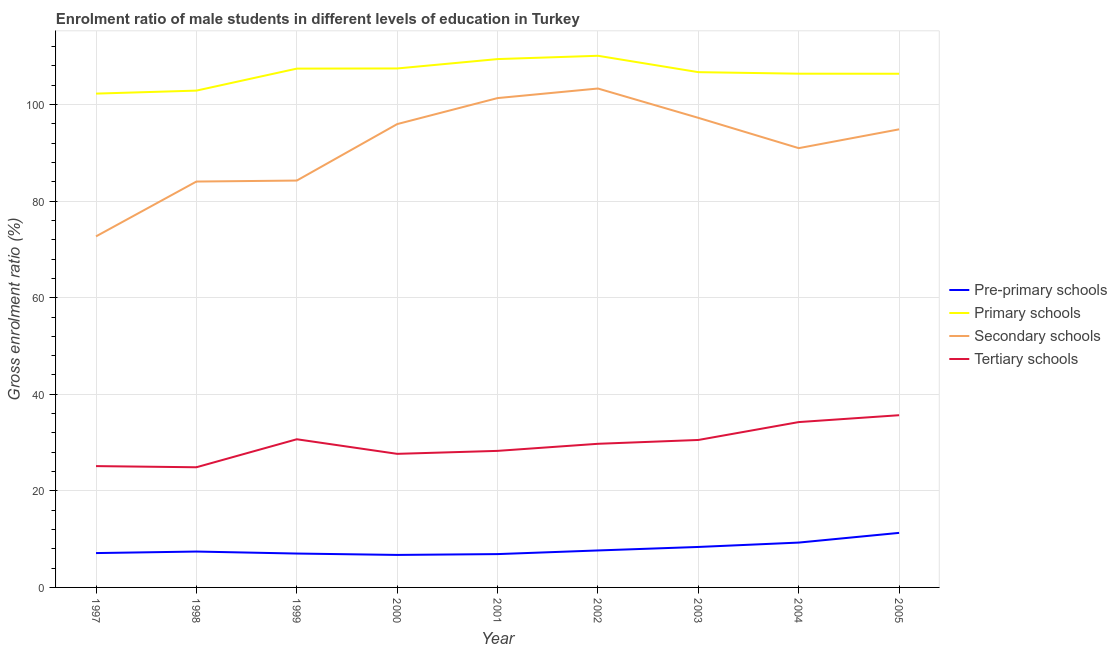How many different coloured lines are there?
Your answer should be very brief. 4. Does the line corresponding to gross enrolment ratio(female) in primary schools intersect with the line corresponding to gross enrolment ratio(female) in pre-primary schools?
Offer a very short reply. No. What is the gross enrolment ratio(female) in secondary schools in 1998?
Provide a short and direct response. 84.06. Across all years, what is the maximum gross enrolment ratio(female) in tertiary schools?
Your answer should be very brief. 35.67. Across all years, what is the minimum gross enrolment ratio(female) in tertiary schools?
Ensure brevity in your answer.  24.89. In which year was the gross enrolment ratio(female) in secondary schools minimum?
Keep it short and to the point. 1997. What is the total gross enrolment ratio(female) in tertiary schools in the graph?
Your response must be concise. 266.83. What is the difference between the gross enrolment ratio(female) in tertiary schools in 1999 and that in 2003?
Your answer should be compact. 0.15. What is the difference between the gross enrolment ratio(female) in pre-primary schools in 2002 and the gross enrolment ratio(female) in secondary schools in 2003?
Offer a terse response. -89.59. What is the average gross enrolment ratio(female) in primary schools per year?
Make the answer very short. 106.57. In the year 1998, what is the difference between the gross enrolment ratio(female) in primary schools and gross enrolment ratio(female) in tertiary schools?
Give a very brief answer. 78. What is the ratio of the gross enrolment ratio(female) in tertiary schools in 2000 to that in 2005?
Your response must be concise. 0.78. Is the difference between the gross enrolment ratio(female) in secondary schools in 2000 and 2003 greater than the difference between the gross enrolment ratio(female) in tertiary schools in 2000 and 2003?
Your response must be concise. Yes. What is the difference between the highest and the second highest gross enrolment ratio(female) in tertiary schools?
Your answer should be very brief. 1.42. What is the difference between the highest and the lowest gross enrolment ratio(female) in pre-primary schools?
Provide a succinct answer. 4.56. In how many years, is the gross enrolment ratio(female) in primary schools greater than the average gross enrolment ratio(female) in primary schools taken over all years?
Offer a terse response. 5. Is it the case that in every year, the sum of the gross enrolment ratio(female) in pre-primary schools and gross enrolment ratio(female) in secondary schools is greater than the sum of gross enrolment ratio(female) in tertiary schools and gross enrolment ratio(female) in primary schools?
Your answer should be very brief. Yes. Is the gross enrolment ratio(female) in pre-primary schools strictly less than the gross enrolment ratio(female) in tertiary schools over the years?
Your response must be concise. Yes. How many lines are there?
Ensure brevity in your answer.  4. How many years are there in the graph?
Provide a succinct answer. 9. What is the difference between two consecutive major ticks on the Y-axis?
Your answer should be very brief. 20. Does the graph contain grids?
Provide a succinct answer. Yes. How many legend labels are there?
Your answer should be very brief. 4. What is the title of the graph?
Provide a short and direct response. Enrolment ratio of male students in different levels of education in Turkey. What is the label or title of the X-axis?
Provide a succinct answer. Year. What is the label or title of the Y-axis?
Provide a succinct answer. Gross enrolment ratio (%). What is the Gross enrolment ratio (%) in Pre-primary schools in 1997?
Give a very brief answer. 7.11. What is the Gross enrolment ratio (%) in Primary schools in 1997?
Your answer should be very brief. 102.27. What is the Gross enrolment ratio (%) of Secondary schools in 1997?
Offer a very short reply. 72.7. What is the Gross enrolment ratio (%) of Tertiary schools in 1997?
Keep it short and to the point. 25.12. What is the Gross enrolment ratio (%) of Pre-primary schools in 1998?
Your answer should be very brief. 7.43. What is the Gross enrolment ratio (%) of Primary schools in 1998?
Provide a succinct answer. 102.89. What is the Gross enrolment ratio (%) in Secondary schools in 1998?
Your answer should be compact. 84.06. What is the Gross enrolment ratio (%) of Tertiary schools in 1998?
Provide a short and direct response. 24.89. What is the Gross enrolment ratio (%) in Pre-primary schools in 1999?
Provide a succinct answer. 7.02. What is the Gross enrolment ratio (%) in Primary schools in 1999?
Offer a very short reply. 107.44. What is the Gross enrolment ratio (%) of Secondary schools in 1999?
Make the answer very short. 84.26. What is the Gross enrolment ratio (%) of Tertiary schools in 1999?
Your response must be concise. 30.68. What is the Gross enrolment ratio (%) in Pre-primary schools in 2000?
Your response must be concise. 6.73. What is the Gross enrolment ratio (%) in Primary schools in 2000?
Make the answer very short. 107.48. What is the Gross enrolment ratio (%) in Secondary schools in 2000?
Ensure brevity in your answer.  95.96. What is the Gross enrolment ratio (%) of Tertiary schools in 2000?
Your response must be concise. 27.66. What is the Gross enrolment ratio (%) in Pre-primary schools in 2001?
Your response must be concise. 6.9. What is the Gross enrolment ratio (%) in Primary schools in 2001?
Give a very brief answer. 109.42. What is the Gross enrolment ratio (%) in Secondary schools in 2001?
Offer a terse response. 101.34. What is the Gross enrolment ratio (%) in Tertiary schools in 2001?
Ensure brevity in your answer.  28.28. What is the Gross enrolment ratio (%) of Pre-primary schools in 2002?
Provide a short and direct response. 7.66. What is the Gross enrolment ratio (%) of Primary schools in 2002?
Ensure brevity in your answer.  110.1. What is the Gross enrolment ratio (%) of Secondary schools in 2002?
Offer a very short reply. 103.32. What is the Gross enrolment ratio (%) of Tertiary schools in 2002?
Ensure brevity in your answer.  29.74. What is the Gross enrolment ratio (%) of Pre-primary schools in 2003?
Offer a very short reply. 8.38. What is the Gross enrolment ratio (%) of Primary schools in 2003?
Offer a terse response. 106.71. What is the Gross enrolment ratio (%) in Secondary schools in 2003?
Provide a succinct answer. 97.25. What is the Gross enrolment ratio (%) of Tertiary schools in 2003?
Offer a very short reply. 30.54. What is the Gross enrolment ratio (%) in Pre-primary schools in 2004?
Your answer should be compact. 9.29. What is the Gross enrolment ratio (%) in Primary schools in 2004?
Your answer should be very brief. 106.39. What is the Gross enrolment ratio (%) of Secondary schools in 2004?
Provide a succinct answer. 90.97. What is the Gross enrolment ratio (%) in Tertiary schools in 2004?
Your answer should be compact. 34.24. What is the Gross enrolment ratio (%) of Pre-primary schools in 2005?
Your answer should be compact. 11.3. What is the Gross enrolment ratio (%) in Primary schools in 2005?
Your answer should be very brief. 106.38. What is the Gross enrolment ratio (%) in Secondary schools in 2005?
Keep it short and to the point. 94.87. What is the Gross enrolment ratio (%) of Tertiary schools in 2005?
Provide a short and direct response. 35.67. Across all years, what is the maximum Gross enrolment ratio (%) of Pre-primary schools?
Keep it short and to the point. 11.3. Across all years, what is the maximum Gross enrolment ratio (%) in Primary schools?
Give a very brief answer. 110.1. Across all years, what is the maximum Gross enrolment ratio (%) of Secondary schools?
Ensure brevity in your answer.  103.32. Across all years, what is the maximum Gross enrolment ratio (%) in Tertiary schools?
Provide a short and direct response. 35.67. Across all years, what is the minimum Gross enrolment ratio (%) in Pre-primary schools?
Make the answer very short. 6.73. Across all years, what is the minimum Gross enrolment ratio (%) of Primary schools?
Your answer should be very brief. 102.27. Across all years, what is the minimum Gross enrolment ratio (%) in Secondary schools?
Your answer should be compact. 72.7. Across all years, what is the minimum Gross enrolment ratio (%) in Tertiary schools?
Offer a terse response. 24.89. What is the total Gross enrolment ratio (%) of Pre-primary schools in the graph?
Offer a terse response. 71.82. What is the total Gross enrolment ratio (%) in Primary schools in the graph?
Make the answer very short. 959.09. What is the total Gross enrolment ratio (%) in Secondary schools in the graph?
Ensure brevity in your answer.  824.73. What is the total Gross enrolment ratio (%) in Tertiary schools in the graph?
Keep it short and to the point. 266.83. What is the difference between the Gross enrolment ratio (%) of Pre-primary schools in 1997 and that in 1998?
Provide a succinct answer. -0.32. What is the difference between the Gross enrolment ratio (%) in Primary schools in 1997 and that in 1998?
Your answer should be very brief. -0.62. What is the difference between the Gross enrolment ratio (%) in Secondary schools in 1997 and that in 1998?
Ensure brevity in your answer.  -11.36. What is the difference between the Gross enrolment ratio (%) in Tertiary schools in 1997 and that in 1998?
Your answer should be very brief. 0.24. What is the difference between the Gross enrolment ratio (%) in Pre-primary schools in 1997 and that in 1999?
Your response must be concise. 0.09. What is the difference between the Gross enrolment ratio (%) of Primary schools in 1997 and that in 1999?
Provide a short and direct response. -5.18. What is the difference between the Gross enrolment ratio (%) in Secondary schools in 1997 and that in 1999?
Keep it short and to the point. -11.56. What is the difference between the Gross enrolment ratio (%) in Tertiary schools in 1997 and that in 1999?
Keep it short and to the point. -5.56. What is the difference between the Gross enrolment ratio (%) of Pre-primary schools in 1997 and that in 2000?
Ensure brevity in your answer.  0.38. What is the difference between the Gross enrolment ratio (%) of Primary schools in 1997 and that in 2000?
Make the answer very short. -5.21. What is the difference between the Gross enrolment ratio (%) in Secondary schools in 1997 and that in 2000?
Offer a very short reply. -23.25. What is the difference between the Gross enrolment ratio (%) of Tertiary schools in 1997 and that in 2000?
Your response must be concise. -2.54. What is the difference between the Gross enrolment ratio (%) of Pre-primary schools in 1997 and that in 2001?
Offer a very short reply. 0.21. What is the difference between the Gross enrolment ratio (%) in Primary schools in 1997 and that in 2001?
Your answer should be very brief. -7.15. What is the difference between the Gross enrolment ratio (%) of Secondary schools in 1997 and that in 2001?
Give a very brief answer. -28.64. What is the difference between the Gross enrolment ratio (%) of Tertiary schools in 1997 and that in 2001?
Keep it short and to the point. -3.16. What is the difference between the Gross enrolment ratio (%) of Pre-primary schools in 1997 and that in 2002?
Ensure brevity in your answer.  -0.55. What is the difference between the Gross enrolment ratio (%) in Primary schools in 1997 and that in 2002?
Provide a succinct answer. -7.83. What is the difference between the Gross enrolment ratio (%) in Secondary schools in 1997 and that in 2002?
Make the answer very short. -30.62. What is the difference between the Gross enrolment ratio (%) of Tertiary schools in 1997 and that in 2002?
Keep it short and to the point. -4.62. What is the difference between the Gross enrolment ratio (%) in Pre-primary schools in 1997 and that in 2003?
Your answer should be very brief. -1.27. What is the difference between the Gross enrolment ratio (%) in Primary schools in 1997 and that in 2003?
Your answer should be very brief. -4.44. What is the difference between the Gross enrolment ratio (%) of Secondary schools in 1997 and that in 2003?
Your answer should be very brief. -24.55. What is the difference between the Gross enrolment ratio (%) of Tertiary schools in 1997 and that in 2003?
Provide a short and direct response. -5.41. What is the difference between the Gross enrolment ratio (%) of Pre-primary schools in 1997 and that in 2004?
Your answer should be very brief. -2.18. What is the difference between the Gross enrolment ratio (%) in Primary schools in 1997 and that in 2004?
Offer a very short reply. -4.12. What is the difference between the Gross enrolment ratio (%) in Secondary schools in 1997 and that in 2004?
Give a very brief answer. -18.27. What is the difference between the Gross enrolment ratio (%) of Tertiary schools in 1997 and that in 2004?
Your answer should be compact. -9.12. What is the difference between the Gross enrolment ratio (%) of Pre-primary schools in 1997 and that in 2005?
Ensure brevity in your answer.  -4.18. What is the difference between the Gross enrolment ratio (%) of Primary schools in 1997 and that in 2005?
Offer a very short reply. -4.11. What is the difference between the Gross enrolment ratio (%) in Secondary schools in 1997 and that in 2005?
Your response must be concise. -22.17. What is the difference between the Gross enrolment ratio (%) in Tertiary schools in 1997 and that in 2005?
Give a very brief answer. -10.54. What is the difference between the Gross enrolment ratio (%) of Pre-primary schools in 1998 and that in 1999?
Offer a very short reply. 0.41. What is the difference between the Gross enrolment ratio (%) in Primary schools in 1998 and that in 1999?
Make the answer very short. -4.56. What is the difference between the Gross enrolment ratio (%) of Secondary schools in 1998 and that in 1999?
Offer a very short reply. -0.2. What is the difference between the Gross enrolment ratio (%) of Tertiary schools in 1998 and that in 1999?
Make the answer very short. -5.8. What is the difference between the Gross enrolment ratio (%) of Pre-primary schools in 1998 and that in 2000?
Provide a succinct answer. 0.7. What is the difference between the Gross enrolment ratio (%) of Primary schools in 1998 and that in 2000?
Offer a terse response. -4.59. What is the difference between the Gross enrolment ratio (%) of Secondary schools in 1998 and that in 2000?
Offer a very short reply. -11.9. What is the difference between the Gross enrolment ratio (%) of Tertiary schools in 1998 and that in 2000?
Your answer should be compact. -2.78. What is the difference between the Gross enrolment ratio (%) in Pre-primary schools in 1998 and that in 2001?
Give a very brief answer. 0.53. What is the difference between the Gross enrolment ratio (%) of Primary schools in 1998 and that in 2001?
Offer a terse response. -6.53. What is the difference between the Gross enrolment ratio (%) in Secondary schools in 1998 and that in 2001?
Ensure brevity in your answer.  -17.29. What is the difference between the Gross enrolment ratio (%) of Tertiary schools in 1998 and that in 2001?
Your answer should be compact. -3.4. What is the difference between the Gross enrolment ratio (%) in Pre-primary schools in 1998 and that in 2002?
Your answer should be compact. -0.23. What is the difference between the Gross enrolment ratio (%) of Primary schools in 1998 and that in 2002?
Give a very brief answer. -7.21. What is the difference between the Gross enrolment ratio (%) of Secondary schools in 1998 and that in 2002?
Provide a short and direct response. -19.27. What is the difference between the Gross enrolment ratio (%) in Tertiary schools in 1998 and that in 2002?
Provide a short and direct response. -4.86. What is the difference between the Gross enrolment ratio (%) of Pre-primary schools in 1998 and that in 2003?
Your answer should be compact. -0.95. What is the difference between the Gross enrolment ratio (%) in Primary schools in 1998 and that in 2003?
Provide a short and direct response. -3.82. What is the difference between the Gross enrolment ratio (%) in Secondary schools in 1998 and that in 2003?
Your answer should be very brief. -13.19. What is the difference between the Gross enrolment ratio (%) in Tertiary schools in 1998 and that in 2003?
Offer a very short reply. -5.65. What is the difference between the Gross enrolment ratio (%) of Pre-primary schools in 1998 and that in 2004?
Your answer should be very brief. -1.86. What is the difference between the Gross enrolment ratio (%) of Primary schools in 1998 and that in 2004?
Your answer should be compact. -3.5. What is the difference between the Gross enrolment ratio (%) of Secondary schools in 1998 and that in 2004?
Your answer should be compact. -6.92. What is the difference between the Gross enrolment ratio (%) of Tertiary schools in 1998 and that in 2004?
Provide a succinct answer. -9.36. What is the difference between the Gross enrolment ratio (%) in Pre-primary schools in 1998 and that in 2005?
Your answer should be very brief. -3.87. What is the difference between the Gross enrolment ratio (%) of Primary schools in 1998 and that in 2005?
Provide a short and direct response. -3.49. What is the difference between the Gross enrolment ratio (%) in Secondary schools in 1998 and that in 2005?
Your answer should be very brief. -10.81. What is the difference between the Gross enrolment ratio (%) in Tertiary schools in 1998 and that in 2005?
Offer a terse response. -10.78. What is the difference between the Gross enrolment ratio (%) of Pre-primary schools in 1999 and that in 2000?
Your response must be concise. 0.28. What is the difference between the Gross enrolment ratio (%) of Primary schools in 1999 and that in 2000?
Provide a succinct answer. -0.03. What is the difference between the Gross enrolment ratio (%) of Secondary schools in 1999 and that in 2000?
Offer a very short reply. -11.7. What is the difference between the Gross enrolment ratio (%) in Tertiary schools in 1999 and that in 2000?
Provide a short and direct response. 3.02. What is the difference between the Gross enrolment ratio (%) in Pre-primary schools in 1999 and that in 2001?
Your response must be concise. 0.11. What is the difference between the Gross enrolment ratio (%) of Primary schools in 1999 and that in 2001?
Keep it short and to the point. -1.97. What is the difference between the Gross enrolment ratio (%) in Secondary schools in 1999 and that in 2001?
Your response must be concise. -17.08. What is the difference between the Gross enrolment ratio (%) of Tertiary schools in 1999 and that in 2001?
Your answer should be very brief. 2.4. What is the difference between the Gross enrolment ratio (%) of Pre-primary schools in 1999 and that in 2002?
Ensure brevity in your answer.  -0.64. What is the difference between the Gross enrolment ratio (%) of Primary schools in 1999 and that in 2002?
Give a very brief answer. -2.66. What is the difference between the Gross enrolment ratio (%) in Secondary schools in 1999 and that in 2002?
Provide a succinct answer. -19.06. What is the difference between the Gross enrolment ratio (%) in Tertiary schools in 1999 and that in 2002?
Your response must be concise. 0.94. What is the difference between the Gross enrolment ratio (%) of Pre-primary schools in 1999 and that in 2003?
Make the answer very short. -1.37. What is the difference between the Gross enrolment ratio (%) in Primary schools in 1999 and that in 2003?
Make the answer very short. 0.73. What is the difference between the Gross enrolment ratio (%) of Secondary schools in 1999 and that in 2003?
Offer a terse response. -12.99. What is the difference between the Gross enrolment ratio (%) of Tertiary schools in 1999 and that in 2003?
Your answer should be compact. 0.15. What is the difference between the Gross enrolment ratio (%) of Pre-primary schools in 1999 and that in 2004?
Keep it short and to the point. -2.27. What is the difference between the Gross enrolment ratio (%) of Primary schools in 1999 and that in 2004?
Your answer should be compact. 1.05. What is the difference between the Gross enrolment ratio (%) of Secondary schools in 1999 and that in 2004?
Give a very brief answer. -6.71. What is the difference between the Gross enrolment ratio (%) in Tertiary schools in 1999 and that in 2004?
Keep it short and to the point. -3.56. What is the difference between the Gross enrolment ratio (%) in Pre-primary schools in 1999 and that in 2005?
Offer a terse response. -4.28. What is the difference between the Gross enrolment ratio (%) in Primary schools in 1999 and that in 2005?
Ensure brevity in your answer.  1.06. What is the difference between the Gross enrolment ratio (%) of Secondary schools in 1999 and that in 2005?
Your response must be concise. -10.61. What is the difference between the Gross enrolment ratio (%) in Tertiary schools in 1999 and that in 2005?
Your answer should be compact. -4.98. What is the difference between the Gross enrolment ratio (%) of Pre-primary schools in 2000 and that in 2001?
Keep it short and to the point. -0.17. What is the difference between the Gross enrolment ratio (%) of Primary schools in 2000 and that in 2001?
Offer a terse response. -1.94. What is the difference between the Gross enrolment ratio (%) of Secondary schools in 2000 and that in 2001?
Your response must be concise. -5.39. What is the difference between the Gross enrolment ratio (%) in Tertiary schools in 2000 and that in 2001?
Your answer should be compact. -0.62. What is the difference between the Gross enrolment ratio (%) of Pre-primary schools in 2000 and that in 2002?
Your answer should be compact. -0.93. What is the difference between the Gross enrolment ratio (%) of Primary schools in 2000 and that in 2002?
Offer a very short reply. -2.62. What is the difference between the Gross enrolment ratio (%) in Secondary schools in 2000 and that in 2002?
Your answer should be very brief. -7.37. What is the difference between the Gross enrolment ratio (%) in Tertiary schools in 2000 and that in 2002?
Your answer should be compact. -2.08. What is the difference between the Gross enrolment ratio (%) in Pre-primary schools in 2000 and that in 2003?
Offer a very short reply. -1.65. What is the difference between the Gross enrolment ratio (%) in Primary schools in 2000 and that in 2003?
Your answer should be very brief. 0.77. What is the difference between the Gross enrolment ratio (%) in Secondary schools in 2000 and that in 2003?
Your response must be concise. -1.29. What is the difference between the Gross enrolment ratio (%) of Tertiary schools in 2000 and that in 2003?
Keep it short and to the point. -2.87. What is the difference between the Gross enrolment ratio (%) in Pre-primary schools in 2000 and that in 2004?
Provide a succinct answer. -2.55. What is the difference between the Gross enrolment ratio (%) in Primary schools in 2000 and that in 2004?
Your response must be concise. 1.08. What is the difference between the Gross enrolment ratio (%) in Secondary schools in 2000 and that in 2004?
Ensure brevity in your answer.  4.98. What is the difference between the Gross enrolment ratio (%) in Tertiary schools in 2000 and that in 2004?
Provide a short and direct response. -6.58. What is the difference between the Gross enrolment ratio (%) in Pre-primary schools in 2000 and that in 2005?
Your answer should be very brief. -4.56. What is the difference between the Gross enrolment ratio (%) of Primary schools in 2000 and that in 2005?
Make the answer very short. 1.1. What is the difference between the Gross enrolment ratio (%) of Secondary schools in 2000 and that in 2005?
Ensure brevity in your answer.  1.08. What is the difference between the Gross enrolment ratio (%) in Tertiary schools in 2000 and that in 2005?
Give a very brief answer. -8. What is the difference between the Gross enrolment ratio (%) in Pre-primary schools in 2001 and that in 2002?
Offer a terse response. -0.75. What is the difference between the Gross enrolment ratio (%) of Primary schools in 2001 and that in 2002?
Ensure brevity in your answer.  -0.68. What is the difference between the Gross enrolment ratio (%) of Secondary schools in 2001 and that in 2002?
Make the answer very short. -1.98. What is the difference between the Gross enrolment ratio (%) of Tertiary schools in 2001 and that in 2002?
Ensure brevity in your answer.  -1.46. What is the difference between the Gross enrolment ratio (%) in Pre-primary schools in 2001 and that in 2003?
Make the answer very short. -1.48. What is the difference between the Gross enrolment ratio (%) of Primary schools in 2001 and that in 2003?
Ensure brevity in your answer.  2.71. What is the difference between the Gross enrolment ratio (%) of Secondary schools in 2001 and that in 2003?
Offer a very short reply. 4.09. What is the difference between the Gross enrolment ratio (%) in Tertiary schools in 2001 and that in 2003?
Provide a short and direct response. -2.26. What is the difference between the Gross enrolment ratio (%) of Pre-primary schools in 2001 and that in 2004?
Give a very brief answer. -2.38. What is the difference between the Gross enrolment ratio (%) of Primary schools in 2001 and that in 2004?
Your answer should be very brief. 3.03. What is the difference between the Gross enrolment ratio (%) in Secondary schools in 2001 and that in 2004?
Ensure brevity in your answer.  10.37. What is the difference between the Gross enrolment ratio (%) of Tertiary schools in 2001 and that in 2004?
Make the answer very short. -5.96. What is the difference between the Gross enrolment ratio (%) of Pre-primary schools in 2001 and that in 2005?
Make the answer very short. -4.39. What is the difference between the Gross enrolment ratio (%) in Primary schools in 2001 and that in 2005?
Provide a succinct answer. 3.04. What is the difference between the Gross enrolment ratio (%) in Secondary schools in 2001 and that in 2005?
Make the answer very short. 6.47. What is the difference between the Gross enrolment ratio (%) in Tertiary schools in 2001 and that in 2005?
Keep it short and to the point. -7.38. What is the difference between the Gross enrolment ratio (%) of Pre-primary schools in 2002 and that in 2003?
Offer a terse response. -0.72. What is the difference between the Gross enrolment ratio (%) in Primary schools in 2002 and that in 2003?
Your answer should be very brief. 3.39. What is the difference between the Gross enrolment ratio (%) of Secondary schools in 2002 and that in 2003?
Make the answer very short. 6.07. What is the difference between the Gross enrolment ratio (%) of Tertiary schools in 2002 and that in 2003?
Give a very brief answer. -0.79. What is the difference between the Gross enrolment ratio (%) of Pre-primary schools in 2002 and that in 2004?
Provide a succinct answer. -1.63. What is the difference between the Gross enrolment ratio (%) in Primary schools in 2002 and that in 2004?
Your response must be concise. 3.71. What is the difference between the Gross enrolment ratio (%) of Secondary schools in 2002 and that in 2004?
Your response must be concise. 12.35. What is the difference between the Gross enrolment ratio (%) in Tertiary schools in 2002 and that in 2004?
Provide a succinct answer. -4.5. What is the difference between the Gross enrolment ratio (%) in Pre-primary schools in 2002 and that in 2005?
Give a very brief answer. -3.64. What is the difference between the Gross enrolment ratio (%) in Primary schools in 2002 and that in 2005?
Offer a very short reply. 3.72. What is the difference between the Gross enrolment ratio (%) in Secondary schools in 2002 and that in 2005?
Ensure brevity in your answer.  8.45. What is the difference between the Gross enrolment ratio (%) of Tertiary schools in 2002 and that in 2005?
Offer a very short reply. -5.92. What is the difference between the Gross enrolment ratio (%) in Pre-primary schools in 2003 and that in 2004?
Keep it short and to the point. -0.9. What is the difference between the Gross enrolment ratio (%) of Primary schools in 2003 and that in 2004?
Offer a terse response. 0.32. What is the difference between the Gross enrolment ratio (%) of Secondary schools in 2003 and that in 2004?
Your answer should be compact. 6.28. What is the difference between the Gross enrolment ratio (%) in Tertiary schools in 2003 and that in 2004?
Your answer should be compact. -3.71. What is the difference between the Gross enrolment ratio (%) in Pre-primary schools in 2003 and that in 2005?
Provide a succinct answer. -2.91. What is the difference between the Gross enrolment ratio (%) in Primary schools in 2003 and that in 2005?
Offer a very short reply. 0.33. What is the difference between the Gross enrolment ratio (%) in Secondary schools in 2003 and that in 2005?
Offer a very short reply. 2.38. What is the difference between the Gross enrolment ratio (%) of Tertiary schools in 2003 and that in 2005?
Make the answer very short. -5.13. What is the difference between the Gross enrolment ratio (%) in Pre-primary schools in 2004 and that in 2005?
Make the answer very short. -2.01. What is the difference between the Gross enrolment ratio (%) of Primary schools in 2004 and that in 2005?
Provide a short and direct response. 0.01. What is the difference between the Gross enrolment ratio (%) in Secondary schools in 2004 and that in 2005?
Ensure brevity in your answer.  -3.9. What is the difference between the Gross enrolment ratio (%) in Tertiary schools in 2004 and that in 2005?
Your response must be concise. -1.42. What is the difference between the Gross enrolment ratio (%) of Pre-primary schools in 1997 and the Gross enrolment ratio (%) of Primary schools in 1998?
Make the answer very short. -95.78. What is the difference between the Gross enrolment ratio (%) in Pre-primary schools in 1997 and the Gross enrolment ratio (%) in Secondary schools in 1998?
Your answer should be very brief. -76.94. What is the difference between the Gross enrolment ratio (%) in Pre-primary schools in 1997 and the Gross enrolment ratio (%) in Tertiary schools in 1998?
Keep it short and to the point. -17.77. What is the difference between the Gross enrolment ratio (%) in Primary schools in 1997 and the Gross enrolment ratio (%) in Secondary schools in 1998?
Provide a succinct answer. 18.21. What is the difference between the Gross enrolment ratio (%) of Primary schools in 1997 and the Gross enrolment ratio (%) of Tertiary schools in 1998?
Ensure brevity in your answer.  77.38. What is the difference between the Gross enrolment ratio (%) of Secondary schools in 1997 and the Gross enrolment ratio (%) of Tertiary schools in 1998?
Your answer should be compact. 47.81. What is the difference between the Gross enrolment ratio (%) of Pre-primary schools in 1997 and the Gross enrolment ratio (%) of Primary schools in 1999?
Make the answer very short. -100.33. What is the difference between the Gross enrolment ratio (%) in Pre-primary schools in 1997 and the Gross enrolment ratio (%) in Secondary schools in 1999?
Your answer should be compact. -77.15. What is the difference between the Gross enrolment ratio (%) in Pre-primary schools in 1997 and the Gross enrolment ratio (%) in Tertiary schools in 1999?
Your answer should be compact. -23.57. What is the difference between the Gross enrolment ratio (%) of Primary schools in 1997 and the Gross enrolment ratio (%) of Secondary schools in 1999?
Provide a succinct answer. 18.01. What is the difference between the Gross enrolment ratio (%) in Primary schools in 1997 and the Gross enrolment ratio (%) in Tertiary schools in 1999?
Your response must be concise. 71.58. What is the difference between the Gross enrolment ratio (%) in Secondary schools in 1997 and the Gross enrolment ratio (%) in Tertiary schools in 1999?
Make the answer very short. 42.02. What is the difference between the Gross enrolment ratio (%) of Pre-primary schools in 1997 and the Gross enrolment ratio (%) of Primary schools in 2000?
Make the answer very short. -100.36. What is the difference between the Gross enrolment ratio (%) in Pre-primary schools in 1997 and the Gross enrolment ratio (%) in Secondary schools in 2000?
Provide a succinct answer. -88.84. What is the difference between the Gross enrolment ratio (%) of Pre-primary schools in 1997 and the Gross enrolment ratio (%) of Tertiary schools in 2000?
Your answer should be compact. -20.55. What is the difference between the Gross enrolment ratio (%) in Primary schools in 1997 and the Gross enrolment ratio (%) in Secondary schools in 2000?
Offer a very short reply. 6.31. What is the difference between the Gross enrolment ratio (%) in Primary schools in 1997 and the Gross enrolment ratio (%) in Tertiary schools in 2000?
Your response must be concise. 74.6. What is the difference between the Gross enrolment ratio (%) of Secondary schools in 1997 and the Gross enrolment ratio (%) of Tertiary schools in 2000?
Make the answer very short. 45.04. What is the difference between the Gross enrolment ratio (%) of Pre-primary schools in 1997 and the Gross enrolment ratio (%) of Primary schools in 2001?
Provide a succinct answer. -102.31. What is the difference between the Gross enrolment ratio (%) in Pre-primary schools in 1997 and the Gross enrolment ratio (%) in Secondary schools in 2001?
Give a very brief answer. -94.23. What is the difference between the Gross enrolment ratio (%) of Pre-primary schools in 1997 and the Gross enrolment ratio (%) of Tertiary schools in 2001?
Make the answer very short. -21.17. What is the difference between the Gross enrolment ratio (%) in Primary schools in 1997 and the Gross enrolment ratio (%) in Secondary schools in 2001?
Your answer should be very brief. 0.93. What is the difference between the Gross enrolment ratio (%) in Primary schools in 1997 and the Gross enrolment ratio (%) in Tertiary schools in 2001?
Your answer should be compact. 73.99. What is the difference between the Gross enrolment ratio (%) of Secondary schools in 1997 and the Gross enrolment ratio (%) of Tertiary schools in 2001?
Your response must be concise. 44.42. What is the difference between the Gross enrolment ratio (%) of Pre-primary schools in 1997 and the Gross enrolment ratio (%) of Primary schools in 2002?
Make the answer very short. -102.99. What is the difference between the Gross enrolment ratio (%) in Pre-primary schools in 1997 and the Gross enrolment ratio (%) in Secondary schools in 2002?
Offer a terse response. -96.21. What is the difference between the Gross enrolment ratio (%) in Pre-primary schools in 1997 and the Gross enrolment ratio (%) in Tertiary schools in 2002?
Your answer should be very brief. -22.63. What is the difference between the Gross enrolment ratio (%) in Primary schools in 1997 and the Gross enrolment ratio (%) in Secondary schools in 2002?
Make the answer very short. -1.05. What is the difference between the Gross enrolment ratio (%) in Primary schools in 1997 and the Gross enrolment ratio (%) in Tertiary schools in 2002?
Provide a short and direct response. 72.52. What is the difference between the Gross enrolment ratio (%) in Secondary schools in 1997 and the Gross enrolment ratio (%) in Tertiary schools in 2002?
Your answer should be very brief. 42.96. What is the difference between the Gross enrolment ratio (%) in Pre-primary schools in 1997 and the Gross enrolment ratio (%) in Primary schools in 2003?
Your answer should be compact. -99.6. What is the difference between the Gross enrolment ratio (%) of Pre-primary schools in 1997 and the Gross enrolment ratio (%) of Secondary schools in 2003?
Give a very brief answer. -90.14. What is the difference between the Gross enrolment ratio (%) in Pre-primary schools in 1997 and the Gross enrolment ratio (%) in Tertiary schools in 2003?
Offer a terse response. -23.43. What is the difference between the Gross enrolment ratio (%) in Primary schools in 1997 and the Gross enrolment ratio (%) in Secondary schools in 2003?
Keep it short and to the point. 5.02. What is the difference between the Gross enrolment ratio (%) of Primary schools in 1997 and the Gross enrolment ratio (%) of Tertiary schools in 2003?
Your response must be concise. 71.73. What is the difference between the Gross enrolment ratio (%) in Secondary schools in 1997 and the Gross enrolment ratio (%) in Tertiary schools in 2003?
Your response must be concise. 42.16. What is the difference between the Gross enrolment ratio (%) of Pre-primary schools in 1997 and the Gross enrolment ratio (%) of Primary schools in 2004?
Keep it short and to the point. -99.28. What is the difference between the Gross enrolment ratio (%) of Pre-primary schools in 1997 and the Gross enrolment ratio (%) of Secondary schools in 2004?
Your answer should be very brief. -83.86. What is the difference between the Gross enrolment ratio (%) of Pre-primary schools in 1997 and the Gross enrolment ratio (%) of Tertiary schools in 2004?
Provide a short and direct response. -27.13. What is the difference between the Gross enrolment ratio (%) of Primary schools in 1997 and the Gross enrolment ratio (%) of Secondary schools in 2004?
Offer a terse response. 11.3. What is the difference between the Gross enrolment ratio (%) of Primary schools in 1997 and the Gross enrolment ratio (%) of Tertiary schools in 2004?
Your response must be concise. 68.03. What is the difference between the Gross enrolment ratio (%) in Secondary schools in 1997 and the Gross enrolment ratio (%) in Tertiary schools in 2004?
Provide a short and direct response. 38.46. What is the difference between the Gross enrolment ratio (%) of Pre-primary schools in 1997 and the Gross enrolment ratio (%) of Primary schools in 2005?
Provide a succinct answer. -99.27. What is the difference between the Gross enrolment ratio (%) in Pre-primary schools in 1997 and the Gross enrolment ratio (%) in Secondary schools in 2005?
Your answer should be very brief. -87.76. What is the difference between the Gross enrolment ratio (%) in Pre-primary schools in 1997 and the Gross enrolment ratio (%) in Tertiary schools in 2005?
Provide a short and direct response. -28.55. What is the difference between the Gross enrolment ratio (%) in Primary schools in 1997 and the Gross enrolment ratio (%) in Secondary schools in 2005?
Keep it short and to the point. 7.4. What is the difference between the Gross enrolment ratio (%) of Primary schools in 1997 and the Gross enrolment ratio (%) of Tertiary schools in 2005?
Offer a terse response. 66.6. What is the difference between the Gross enrolment ratio (%) of Secondary schools in 1997 and the Gross enrolment ratio (%) of Tertiary schools in 2005?
Give a very brief answer. 37.04. What is the difference between the Gross enrolment ratio (%) in Pre-primary schools in 1998 and the Gross enrolment ratio (%) in Primary schools in 1999?
Your response must be concise. -100.01. What is the difference between the Gross enrolment ratio (%) in Pre-primary schools in 1998 and the Gross enrolment ratio (%) in Secondary schools in 1999?
Provide a short and direct response. -76.83. What is the difference between the Gross enrolment ratio (%) in Pre-primary schools in 1998 and the Gross enrolment ratio (%) in Tertiary schools in 1999?
Provide a succinct answer. -23.25. What is the difference between the Gross enrolment ratio (%) of Primary schools in 1998 and the Gross enrolment ratio (%) of Secondary schools in 1999?
Ensure brevity in your answer.  18.63. What is the difference between the Gross enrolment ratio (%) in Primary schools in 1998 and the Gross enrolment ratio (%) in Tertiary schools in 1999?
Your answer should be compact. 72.2. What is the difference between the Gross enrolment ratio (%) of Secondary schools in 1998 and the Gross enrolment ratio (%) of Tertiary schools in 1999?
Provide a succinct answer. 53.37. What is the difference between the Gross enrolment ratio (%) in Pre-primary schools in 1998 and the Gross enrolment ratio (%) in Primary schools in 2000?
Your answer should be compact. -100.05. What is the difference between the Gross enrolment ratio (%) of Pre-primary schools in 1998 and the Gross enrolment ratio (%) of Secondary schools in 2000?
Keep it short and to the point. -88.52. What is the difference between the Gross enrolment ratio (%) of Pre-primary schools in 1998 and the Gross enrolment ratio (%) of Tertiary schools in 2000?
Offer a terse response. -20.23. What is the difference between the Gross enrolment ratio (%) of Primary schools in 1998 and the Gross enrolment ratio (%) of Secondary schools in 2000?
Offer a very short reply. 6.93. What is the difference between the Gross enrolment ratio (%) in Primary schools in 1998 and the Gross enrolment ratio (%) in Tertiary schools in 2000?
Your answer should be very brief. 75.22. What is the difference between the Gross enrolment ratio (%) of Secondary schools in 1998 and the Gross enrolment ratio (%) of Tertiary schools in 2000?
Your response must be concise. 56.39. What is the difference between the Gross enrolment ratio (%) in Pre-primary schools in 1998 and the Gross enrolment ratio (%) in Primary schools in 2001?
Your response must be concise. -101.99. What is the difference between the Gross enrolment ratio (%) in Pre-primary schools in 1998 and the Gross enrolment ratio (%) in Secondary schools in 2001?
Ensure brevity in your answer.  -93.91. What is the difference between the Gross enrolment ratio (%) in Pre-primary schools in 1998 and the Gross enrolment ratio (%) in Tertiary schools in 2001?
Ensure brevity in your answer.  -20.85. What is the difference between the Gross enrolment ratio (%) in Primary schools in 1998 and the Gross enrolment ratio (%) in Secondary schools in 2001?
Make the answer very short. 1.55. What is the difference between the Gross enrolment ratio (%) of Primary schools in 1998 and the Gross enrolment ratio (%) of Tertiary schools in 2001?
Your answer should be very brief. 74.61. What is the difference between the Gross enrolment ratio (%) in Secondary schools in 1998 and the Gross enrolment ratio (%) in Tertiary schools in 2001?
Keep it short and to the point. 55.78. What is the difference between the Gross enrolment ratio (%) of Pre-primary schools in 1998 and the Gross enrolment ratio (%) of Primary schools in 2002?
Ensure brevity in your answer.  -102.67. What is the difference between the Gross enrolment ratio (%) of Pre-primary schools in 1998 and the Gross enrolment ratio (%) of Secondary schools in 2002?
Provide a short and direct response. -95.89. What is the difference between the Gross enrolment ratio (%) of Pre-primary schools in 1998 and the Gross enrolment ratio (%) of Tertiary schools in 2002?
Provide a succinct answer. -22.31. What is the difference between the Gross enrolment ratio (%) in Primary schools in 1998 and the Gross enrolment ratio (%) in Secondary schools in 2002?
Your answer should be compact. -0.43. What is the difference between the Gross enrolment ratio (%) of Primary schools in 1998 and the Gross enrolment ratio (%) of Tertiary schools in 2002?
Offer a terse response. 73.14. What is the difference between the Gross enrolment ratio (%) in Secondary schools in 1998 and the Gross enrolment ratio (%) in Tertiary schools in 2002?
Your response must be concise. 54.31. What is the difference between the Gross enrolment ratio (%) in Pre-primary schools in 1998 and the Gross enrolment ratio (%) in Primary schools in 2003?
Provide a succinct answer. -99.28. What is the difference between the Gross enrolment ratio (%) in Pre-primary schools in 1998 and the Gross enrolment ratio (%) in Secondary schools in 2003?
Offer a terse response. -89.82. What is the difference between the Gross enrolment ratio (%) of Pre-primary schools in 1998 and the Gross enrolment ratio (%) of Tertiary schools in 2003?
Give a very brief answer. -23.11. What is the difference between the Gross enrolment ratio (%) in Primary schools in 1998 and the Gross enrolment ratio (%) in Secondary schools in 2003?
Provide a succinct answer. 5.64. What is the difference between the Gross enrolment ratio (%) of Primary schools in 1998 and the Gross enrolment ratio (%) of Tertiary schools in 2003?
Provide a short and direct response. 72.35. What is the difference between the Gross enrolment ratio (%) of Secondary schools in 1998 and the Gross enrolment ratio (%) of Tertiary schools in 2003?
Offer a very short reply. 53.52. What is the difference between the Gross enrolment ratio (%) in Pre-primary schools in 1998 and the Gross enrolment ratio (%) in Primary schools in 2004?
Provide a short and direct response. -98.96. What is the difference between the Gross enrolment ratio (%) in Pre-primary schools in 1998 and the Gross enrolment ratio (%) in Secondary schools in 2004?
Your response must be concise. -83.54. What is the difference between the Gross enrolment ratio (%) of Pre-primary schools in 1998 and the Gross enrolment ratio (%) of Tertiary schools in 2004?
Ensure brevity in your answer.  -26.81. What is the difference between the Gross enrolment ratio (%) in Primary schools in 1998 and the Gross enrolment ratio (%) in Secondary schools in 2004?
Make the answer very short. 11.92. What is the difference between the Gross enrolment ratio (%) of Primary schools in 1998 and the Gross enrolment ratio (%) of Tertiary schools in 2004?
Keep it short and to the point. 68.65. What is the difference between the Gross enrolment ratio (%) in Secondary schools in 1998 and the Gross enrolment ratio (%) in Tertiary schools in 2004?
Offer a terse response. 49.81. What is the difference between the Gross enrolment ratio (%) in Pre-primary schools in 1998 and the Gross enrolment ratio (%) in Primary schools in 2005?
Keep it short and to the point. -98.95. What is the difference between the Gross enrolment ratio (%) in Pre-primary schools in 1998 and the Gross enrolment ratio (%) in Secondary schools in 2005?
Provide a short and direct response. -87.44. What is the difference between the Gross enrolment ratio (%) of Pre-primary schools in 1998 and the Gross enrolment ratio (%) of Tertiary schools in 2005?
Keep it short and to the point. -28.23. What is the difference between the Gross enrolment ratio (%) of Primary schools in 1998 and the Gross enrolment ratio (%) of Secondary schools in 2005?
Keep it short and to the point. 8.02. What is the difference between the Gross enrolment ratio (%) of Primary schools in 1998 and the Gross enrolment ratio (%) of Tertiary schools in 2005?
Provide a succinct answer. 67.22. What is the difference between the Gross enrolment ratio (%) of Secondary schools in 1998 and the Gross enrolment ratio (%) of Tertiary schools in 2005?
Your answer should be compact. 48.39. What is the difference between the Gross enrolment ratio (%) in Pre-primary schools in 1999 and the Gross enrolment ratio (%) in Primary schools in 2000?
Your answer should be very brief. -100.46. What is the difference between the Gross enrolment ratio (%) of Pre-primary schools in 1999 and the Gross enrolment ratio (%) of Secondary schools in 2000?
Provide a short and direct response. -88.94. What is the difference between the Gross enrolment ratio (%) of Pre-primary schools in 1999 and the Gross enrolment ratio (%) of Tertiary schools in 2000?
Your answer should be very brief. -20.65. What is the difference between the Gross enrolment ratio (%) of Primary schools in 1999 and the Gross enrolment ratio (%) of Secondary schools in 2000?
Offer a very short reply. 11.49. What is the difference between the Gross enrolment ratio (%) in Primary schools in 1999 and the Gross enrolment ratio (%) in Tertiary schools in 2000?
Keep it short and to the point. 79.78. What is the difference between the Gross enrolment ratio (%) in Secondary schools in 1999 and the Gross enrolment ratio (%) in Tertiary schools in 2000?
Give a very brief answer. 56.6. What is the difference between the Gross enrolment ratio (%) in Pre-primary schools in 1999 and the Gross enrolment ratio (%) in Primary schools in 2001?
Provide a succinct answer. -102.4. What is the difference between the Gross enrolment ratio (%) of Pre-primary schools in 1999 and the Gross enrolment ratio (%) of Secondary schools in 2001?
Your answer should be compact. -94.32. What is the difference between the Gross enrolment ratio (%) in Pre-primary schools in 1999 and the Gross enrolment ratio (%) in Tertiary schools in 2001?
Offer a terse response. -21.26. What is the difference between the Gross enrolment ratio (%) in Primary schools in 1999 and the Gross enrolment ratio (%) in Secondary schools in 2001?
Your answer should be very brief. 6.1. What is the difference between the Gross enrolment ratio (%) of Primary schools in 1999 and the Gross enrolment ratio (%) of Tertiary schools in 2001?
Make the answer very short. 79.16. What is the difference between the Gross enrolment ratio (%) of Secondary schools in 1999 and the Gross enrolment ratio (%) of Tertiary schools in 2001?
Offer a terse response. 55.98. What is the difference between the Gross enrolment ratio (%) of Pre-primary schools in 1999 and the Gross enrolment ratio (%) of Primary schools in 2002?
Ensure brevity in your answer.  -103.08. What is the difference between the Gross enrolment ratio (%) in Pre-primary schools in 1999 and the Gross enrolment ratio (%) in Secondary schools in 2002?
Ensure brevity in your answer.  -96.31. What is the difference between the Gross enrolment ratio (%) in Pre-primary schools in 1999 and the Gross enrolment ratio (%) in Tertiary schools in 2002?
Offer a very short reply. -22.73. What is the difference between the Gross enrolment ratio (%) of Primary schools in 1999 and the Gross enrolment ratio (%) of Secondary schools in 2002?
Give a very brief answer. 4.12. What is the difference between the Gross enrolment ratio (%) of Primary schools in 1999 and the Gross enrolment ratio (%) of Tertiary schools in 2002?
Offer a very short reply. 77.7. What is the difference between the Gross enrolment ratio (%) in Secondary schools in 1999 and the Gross enrolment ratio (%) in Tertiary schools in 2002?
Your response must be concise. 54.52. What is the difference between the Gross enrolment ratio (%) in Pre-primary schools in 1999 and the Gross enrolment ratio (%) in Primary schools in 2003?
Your answer should be very brief. -99.69. What is the difference between the Gross enrolment ratio (%) in Pre-primary schools in 1999 and the Gross enrolment ratio (%) in Secondary schools in 2003?
Provide a succinct answer. -90.23. What is the difference between the Gross enrolment ratio (%) in Pre-primary schools in 1999 and the Gross enrolment ratio (%) in Tertiary schools in 2003?
Keep it short and to the point. -23.52. What is the difference between the Gross enrolment ratio (%) in Primary schools in 1999 and the Gross enrolment ratio (%) in Secondary schools in 2003?
Your response must be concise. 10.2. What is the difference between the Gross enrolment ratio (%) in Primary schools in 1999 and the Gross enrolment ratio (%) in Tertiary schools in 2003?
Provide a short and direct response. 76.91. What is the difference between the Gross enrolment ratio (%) of Secondary schools in 1999 and the Gross enrolment ratio (%) of Tertiary schools in 2003?
Make the answer very short. 53.72. What is the difference between the Gross enrolment ratio (%) of Pre-primary schools in 1999 and the Gross enrolment ratio (%) of Primary schools in 2004?
Provide a succinct answer. -99.37. What is the difference between the Gross enrolment ratio (%) of Pre-primary schools in 1999 and the Gross enrolment ratio (%) of Secondary schools in 2004?
Keep it short and to the point. -83.96. What is the difference between the Gross enrolment ratio (%) in Pre-primary schools in 1999 and the Gross enrolment ratio (%) in Tertiary schools in 2004?
Your answer should be compact. -27.23. What is the difference between the Gross enrolment ratio (%) in Primary schools in 1999 and the Gross enrolment ratio (%) in Secondary schools in 2004?
Your answer should be very brief. 16.47. What is the difference between the Gross enrolment ratio (%) in Primary schools in 1999 and the Gross enrolment ratio (%) in Tertiary schools in 2004?
Keep it short and to the point. 73.2. What is the difference between the Gross enrolment ratio (%) in Secondary schools in 1999 and the Gross enrolment ratio (%) in Tertiary schools in 2004?
Provide a succinct answer. 50.02. What is the difference between the Gross enrolment ratio (%) in Pre-primary schools in 1999 and the Gross enrolment ratio (%) in Primary schools in 2005?
Your answer should be compact. -99.36. What is the difference between the Gross enrolment ratio (%) in Pre-primary schools in 1999 and the Gross enrolment ratio (%) in Secondary schools in 2005?
Your answer should be very brief. -87.85. What is the difference between the Gross enrolment ratio (%) of Pre-primary schools in 1999 and the Gross enrolment ratio (%) of Tertiary schools in 2005?
Offer a terse response. -28.65. What is the difference between the Gross enrolment ratio (%) in Primary schools in 1999 and the Gross enrolment ratio (%) in Secondary schools in 2005?
Provide a succinct answer. 12.57. What is the difference between the Gross enrolment ratio (%) in Primary schools in 1999 and the Gross enrolment ratio (%) in Tertiary schools in 2005?
Offer a terse response. 71.78. What is the difference between the Gross enrolment ratio (%) of Secondary schools in 1999 and the Gross enrolment ratio (%) of Tertiary schools in 2005?
Your response must be concise. 48.59. What is the difference between the Gross enrolment ratio (%) in Pre-primary schools in 2000 and the Gross enrolment ratio (%) in Primary schools in 2001?
Make the answer very short. -102.69. What is the difference between the Gross enrolment ratio (%) of Pre-primary schools in 2000 and the Gross enrolment ratio (%) of Secondary schools in 2001?
Your answer should be compact. -94.61. What is the difference between the Gross enrolment ratio (%) of Pre-primary schools in 2000 and the Gross enrolment ratio (%) of Tertiary schools in 2001?
Give a very brief answer. -21.55. What is the difference between the Gross enrolment ratio (%) in Primary schools in 2000 and the Gross enrolment ratio (%) in Secondary schools in 2001?
Your answer should be very brief. 6.13. What is the difference between the Gross enrolment ratio (%) of Primary schools in 2000 and the Gross enrolment ratio (%) of Tertiary schools in 2001?
Ensure brevity in your answer.  79.2. What is the difference between the Gross enrolment ratio (%) in Secondary schools in 2000 and the Gross enrolment ratio (%) in Tertiary schools in 2001?
Provide a succinct answer. 67.67. What is the difference between the Gross enrolment ratio (%) of Pre-primary schools in 2000 and the Gross enrolment ratio (%) of Primary schools in 2002?
Your answer should be very brief. -103.37. What is the difference between the Gross enrolment ratio (%) in Pre-primary schools in 2000 and the Gross enrolment ratio (%) in Secondary schools in 2002?
Your response must be concise. -96.59. What is the difference between the Gross enrolment ratio (%) in Pre-primary schools in 2000 and the Gross enrolment ratio (%) in Tertiary schools in 2002?
Provide a succinct answer. -23.01. What is the difference between the Gross enrolment ratio (%) in Primary schools in 2000 and the Gross enrolment ratio (%) in Secondary schools in 2002?
Your answer should be very brief. 4.15. What is the difference between the Gross enrolment ratio (%) of Primary schools in 2000 and the Gross enrolment ratio (%) of Tertiary schools in 2002?
Your answer should be compact. 77.73. What is the difference between the Gross enrolment ratio (%) in Secondary schools in 2000 and the Gross enrolment ratio (%) in Tertiary schools in 2002?
Provide a short and direct response. 66.21. What is the difference between the Gross enrolment ratio (%) in Pre-primary schools in 2000 and the Gross enrolment ratio (%) in Primary schools in 2003?
Provide a short and direct response. -99.98. What is the difference between the Gross enrolment ratio (%) of Pre-primary schools in 2000 and the Gross enrolment ratio (%) of Secondary schools in 2003?
Offer a very short reply. -90.52. What is the difference between the Gross enrolment ratio (%) of Pre-primary schools in 2000 and the Gross enrolment ratio (%) of Tertiary schools in 2003?
Provide a succinct answer. -23.8. What is the difference between the Gross enrolment ratio (%) of Primary schools in 2000 and the Gross enrolment ratio (%) of Secondary schools in 2003?
Provide a succinct answer. 10.23. What is the difference between the Gross enrolment ratio (%) of Primary schools in 2000 and the Gross enrolment ratio (%) of Tertiary schools in 2003?
Keep it short and to the point. 76.94. What is the difference between the Gross enrolment ratio (%) in Secondary schools in 2000 and the Gross enrolment ratio (%) in Tertiary schools in 2003?
Your answer should be very brief. 65.42. What is the difference between the Gross enrolment ratio (%) of Pre-primary schools in 2000 and the Gross enrolment ratio (%) of Primary schools in 2004?
Your response must be concise. -99.66. What is the difference between the Gross enrolment ratio (%) in Pre-primary schools in 2000 and the Gross enrolment ratio (%) in Secondary schools in 2004?
Make the answer very short. -84.24. What is the difference between the Gross enrolment ratio (%) in Pre-primary schools in 2000 and the Gross enrolment ratio (%) in Tertiary schools in 2004?
Provide a short and direct response. -27.51. What is the difference between the Gross enrolment ratio (%) of Primary schools in 2000 and the Gross enrolment ratio (%) of Secondary schools in 2004?
Provide a short and direct response. 16.5. What is the difference between the Gross enrolment ratio (%) in Primary schools in 2000 and the Gross enrolment ratio (%) in Tertiary schools in 2004?
Offer a very short reply. 73.23. What is the difference between the Gross enrolment ratio (%) of Secondary schools in 2000 and the Gross enrolment ratio (%) of Tertiary schools in 2004?
Provide a succinct answer. 61.71. What is the difference between the Gross enrolment ratio (%) of Pre-primary schools in 2000 and the Gross enrolment ratio (%) of Primary schools in 2005?
Your answer should be very brief. -99.65. What is the difference between the Gross enrolment ratio (%) of Pre-primary schools in 2000 and the Gross enrolment ratio (%) of Secondary schools in 2005?
Make the answer very short. -88.14. What is the difference between the Gross enrolment ratio (%) in Pre-primary schools in 2000 and the Gross enrolment ratio (%) in Tertiary schools in 2005?
Ensure brevity in your answer.  -28.93. What is the difference between the Gross enrolment ratio (%) of Primary schools in 2000 and the Gross enrolment ratio (%) of Secondary schools in 2005?
Give a very brief answer. 12.61. What is the difference between the Gross enrolment ratio (%) of Primary schools in 2000 and the Gross enrolment ratio (%) of Tertiary schools in 2005?
Ensure brevity in your answer.  71.81. What is the difference between the Gross enrolment ratio (%) of Secondary schools in 2000 and the Gross enrolment ratio (%) of Tertiary schools in 2005?
Provide a succinct answer. 60.29. What is the difference between the Gross enrolment ratio (%) of Pre-primary schools in 2001 and the Gross enrolment ratio (%) of Primary schools in 2002?
Your response must be concise. -103.2. What is the difference between the Gross enrolment ratio (%) of Pre-primary schools in 2001 and the Gross enrolment ratio (%) of Secondary schools in 2002?
Keep it short and to the point. -96.42. What is the difference between the Gross enrolment ratio (%) of Pre-primary schools in 2001 and the Gross enrolment ratio (%) of Tertiary schools in 2002?
Your answer should be very brief. -22.84. What is the difference between the Gross enrolment ratio (%) in Primary schools in 2001 and the Gross enrolment ratio (%) in Secondary schools in 2002?
Ensure brevity in your answer.  6.1. What is the difference between the Gross enrolment ratio (%) of Primary schools in 2001 and the Gross enrolment ratio (%) of Tertiary schools in 2002?
Make the answer very short. 79.67. What is the difference between the Gross enrolment ratio (%) in Secondary schools in 2001 and the Gross enrolment ratio (%) in Tertiary schools in 2002?
Make the answer very short. 71.6. What is the difference between the Gross enrolment ratio (%) in Pre-primary schools in 2001 and the Gross enrolment ratio (%) in Primary schools in 2003?
Your answer should be very brief. -99.81. What is the difference between the Gross enrolment ratio (%) of Pre-primary schools in 2001 and the Gross enrolment ratio (%) of Secondary schools in 2003?
Keep it short and to the point. -90.34. What is the difference between the Gross enrolment ratio (%) of Pre-primary schools in 2001 and the Gross enrolment ratio (%) of Tertiary schools in 2003?
Ensure brevity in your answer.  -23.63. What is the difference between the Gross enrolment ratio (%) in Primary schools in 2001 and the Gross enrolment ratio (%) in Secondary schools in 2003?
Offer a terse response. 12.17. What is the difference between the Gross enrolment ratio (%) of Primary schools in 2001 and the Gross enrolment ratio (%) of Tertiary schools in 2003?
Your answer should be very brief. 78.88. What is the difference between the Gross enrolment ratio (%) of Secondary schools in 2001 and the Gross enrolment ratio (%) of Tertiary schools in 2003?
Keep it short and to the point. 70.8. What is the difference between the Gross enrolment ratio (%) in Pre-primary schools in 2001 and the Gross enrolment ratio (%) in Primary schools in 2004?
Ensure brevity in your answer.  -99.49. What is the difference between the Gross enrolment ratio (%) in Pre-primary schools in 2001 and the Gross enrolment ratio (%) in Secondary schools in 2004?
Give a very brief answer. -84.07. What is the difference between the Gross enrolment ratio (%) in Pre-primary schools in 2001 and the Gross enrolment ratio (%) in Tertiary schools in 2004?
Your answer should be very brief. -27.34. What is the difference between the Gross enrolment ratio (%) of Primary schools in 2001 and the Gross enrolment ratio (%) of Secondary schools in 2004?
Provide a succinct answer. 18.45. What is the difference between the Gross enrolment ratio (%) of Primary schools in 2001 and the Gross enrolment ratio (%) of Tertiary schools in 2004?
Keep it short and to the point. 75.18. What is the difference between the Gross enrolment ratio (%) in Secondary schools in 2001 and the Gross enrolment ratio (%) in Tertiary schools in 2004?
Offer a terse response. 67.1. What is the difference between the Gross enrolment ratio (%) of Pre-primary schools in 2001 and the Gross enrolment ratio (%) of Primary schools in 2005?
Provide a short and direct response. -99.48. What is the difference between the Gross enrolment ratio (%) of Pre-primary schools in 2001 and the Gross enrolment ratio (%) of Secondary schools in 2005?
Your answer should be compact. -87.97. What is the difference between the Gross enrolment ratio (%) of Pre-primary schools in 2001 and the Gross enrolment ratio (%) of Tertiary schools in 2005?
Your answer should be very brief. -28.76. What is the difference between the Gross enrolment ratio (%) of Primary schools in 2001 and the Gross enrolment ratio (%) of Secondary schools in 2005?
Provide a succinct answer. 14.55. What is the difference between the Gross enrolment ratio (%) of Primary schools in 2001 and the Gross enrolment ratio (%) of Tertiary schools in 2005?
Provide a succinct answer. 73.75. What is the difference between the Gross enrolment ratio (%) in Secondary schools in 2001 and the Gross enrolment ratio (%) in Tertiary schools in 2005?
Your answer should be compact. 65.68. What is the difference between the Gross enrolment ratio (%) of Pre-primary schools in 2002 and the Gross enrolment ratio (%) of Primary schools in 2003?
Provide a short and direct response. -99.05. What is the difference between the Gross enrolment ratio (%) in Pre-primary schools in 2002 and the Gross enrolment ratio (%) in Secondary schools in 2003?
Keep it short and to the point. -89.59. What is the difference between the Gross enrolment ratio (%) in Pre-primary schools in 2002 and the Gross enrolment ratio (%) in Tertiary schools in 2003?
Provide a succinct answer. -22.88. What is the difference between the Gross enrolment ratio (%) in Primary schools in 2002 and the Gross enrolment ratio (%) in Secondary schools in 2003?
Your answer should be compact. 12.85. What is the difference between the Gross enrolment ratio (%) in Primary schools in 2002 and the Gross enrolment ratio (%) in Tertiary schools in 2003?
Provide a short and direct response. 79.56. What is the difference between the Gross enrolment ratio (%) in Secondary schools in 2002 and the Gross enrolment ratio (%) in Tertiary schools in 2003?
Your response must be concise. 72.79. What is the difference between the Gross enrolment ratio (%) in Pre-primary schools in 2002 and the Gross enrolment ratio (%) in Primary schools in 2004?
Provide a short and direct response. -98.73. What is the difference between the Gross enrolment ratio (%) in Pre-primary schools in 2002 and the Gross enrolment ratio (%) in Secondary schools in 2004?
Keep it short and to the point. -83.31. What is the difference between the Gross enrolment ratio (%) of Pre-primary schools in 2002 and the Gross enrolment ratio (%) of Tertiary schools in 2004?
Provide a succinct answer. -26.58. What is the difference between the Gross enrolment ratio (%) of Primary schools in 2002 and the Gross enrolment ratio (%) of Secondary schools in 2004?
Offer a terse response. 19.13. What is the difference between the Gross enrolment ratio (%) of Primary schools in 2002 and the Gross enrolment ratio (%) of Tertiary schools in 2004?
Provide a succinct answer. 75.86. What is the difference between the Gross enrolment ratio (%) of Secondary schools in 2002 and the Gross enrolment ratio (%) of Tertiary schools in 2004?
Your answer should be compact. 69.08. What is the difference between the Gross enrolment ratio (%) of Pre-primary schools in 2002 and the Gross enrolment ratio (%) of Primary schools in 2005?
Your response must be concise. -98.72. What is the difference between the Gross enrolment ratio (%) in Pre-primary schools in 2002 and the Gross enrolment ratio (%) in Secondary schools in 2005?
Provide a short and direct response. -87.21. What is the difference between the Gross enrolment ratio (%) in Pre-primary schools in 2002 and the Gross enrolment ratio (%) in Tertiary schools in 2005?
Your answer should be very brief. -28.01. What is the difference between the Gross enrolment ratio (%) of Primary schools in 2002 and the Gross enrolment ratio (%) of Secondary schools in 2005?
Provide a succinct answer. 15.23. What is the difference between the Gross enrolment ratio (%) in Primary schools in 2002 and the Gross enrolment ratio (%) in Tertiary schools in 2005?
Ensure brevity in your answer.  74.44. What is the difference between the Gross enrolment ratio (%) in Secondary schools in 2002 and the Gross enrolment ratio (%) in Tertiary schools in 2005?
Provide a short and direct response. 67.66. What is the difference between the Gross enrolment ratio (%) in Pre-primary schools in 2003 and the Gross enrolment ratio (%) in Primary schools in 2004?
Offer a terse response. -98.01. What is the difference between the Gross enrolment ratio (%) in Pre-primary schools in 2003 and the Gross enrolment ratio (%) in Secondary schools in 2004?
Make the answer very short. -82.59. What is the difference between the Gross enrolment ratio (%) in Pre-primary schools in 2003 and the Gross enrolment ratio (%) in Tertiary schools in 2004?
Ensure brevity in your answer.  -25.86. What is the difference between the Gross enrolment ratio (%) of Primary schools in 2003 and the Gross enrolment ratio (%) of Secondary schools in 2004?
Keep it short and to the point. 15.74. What is the difference between the Gross enrolment ratio (%) of Primary schools in 2003 and the Gross enrolment ratio (%) of Tertiary schools in 2004?
Your answer should be very brief. 72.47. What is the difference between the Gross enrolment ratio (%) of Secondary schools in 2003 and the Gross enrolment ratio (%) of Tertiary schools in 2004?
Your answer should be very brief. 63.01. What is the difference between the Gross enrolment ratio (%) in Pre-primary schools in 2003 and the Gross enrolment ratio (%) in Primary schools in 2005?
Your answer should be very brief. -98. What is the difference between the Gross enrolment ratio (%) of Pre-primary schools in 2003 and the Gross enrolment ratio (%) of Secondary schools in 2005?
Keep it short and to the point. -86.49. What is the difference between the Gross enrolment ratio (%) in Pre-primary schools in 2003 and the Gross enrolment ratio (%) in Tertiary schools in 2005?
Give a very brief answer. -27.28. What is the difference between the Gross enrolment ratio (%) in Primary schools in 2003 and the Gross enrolment ratio (%) in Secondary schools in 2005?
Make the answer very short. 11.84. What is the difference between the Gross enrolment ratio (%) of Primary schools in 2003 and the Gross enrolment ratio (%) of Tertiary schools in 2005?
Your response must be concise. 71.05. What is the difference between the Gross enrolment ratio (%) of Secondary schools in 2003 and the Gross enrolment ratio (%) of Tertiary schools in 2005?
Offer a terse response. 61.58. What is the difference between the Gross enrolment ratio (%) in Pre-primary schools in 2004 and the Gross enrolment ratio (%) in Primary schools in 2005?
Your answer should be compact. -97.09. What is the difference between the Gross enrolment ratio (%) of Pre-primary schools in 2004 and the Gross enrolment ratio (%) of Secondary schools in 2005?
Your answer should be compact. -85.58. What is the difference between the Gross enrolment ratio (%) in Pre-primary schools in 2004 and the Gross enrolment ratio (%) in Tertiary schools in 2005?
Your answer should be very brief. -26.38. What is the difference between the Gross enrolment ratio (%) in Primary schools in 2004 and the Gross enrolment ratio (%) in Secondary schools in 2005?
Provide a succinct answer. 11.52. What is the difference between the Gross enrolment ratio (%) of Primary schools in 2004 and the Gross enrolment ratio (%) of Tertiary schools in 2005?
Your response must be concise. 70.73. What is the difference between the Gross enrolment ratio (%) in Secondary schools in 2004 and the Gross enrolment ratio (%) in Tertiary schools in 2005?
Ensure brevity in your answer.  55.31. What is the average Gross enrolment ratio (%) of Pre-primary schools per year?
Ensure brevity in your answer.  7.98. What is the average Gross enrolment ratio (%) of Primary schools per year?
Offer a terse response. 106.56. What is the average Gross enrolment ratio (%) of Secondary schools per year?
Provide a succinct answer. 91.64. What is the average Gross enrolment ratio (%) of Tertiary schools per year?
Ensure brevity in your answer.  29.65. In the year 1997, what is the difference between the Gross enrolment ratio (%) in Pre-primary schools and Gross enrolment ratio (%) in Primary schools?
Ensure brevity in your answer.  -95.16. In the year 1997, what is the difference between the Gross enrolment ratio (%) of Pre-primary schools and Gross enrolment ratio (%) of Secondary schools?
Your response must be concise. -65.59. In the year 1997, what is the difference between the Gross enrolment ratio (%) in Pre-primary schools and Gross enrolment ratio (%) in Tertiary schools?
Provide a short and direct response. -18.01. In the year 1997, what is the difference between the Gross enrolment ratio (%) in Primary schools and Gross enrolment ratio (%) in Secondary schools?
Make the answer very short. 29.57. In the year 1997, what is the difference between the Gross enrolment ratio (%) of Primary schools and Gross enrolment ratio (%) of Tertiary schools?
Offer a terse response. 77.14. In the year 1997, what is the difference between the Gross enrolment ratio (%) of Secondary schools and Gross enrolment ratio (%) of Tertiary schools?
Give a very brief answer. 47.58. In the year 1998, what is the difference between the Gross enrolment ratio (%) of Pre-primary schools and Gross enrolment ratio (%) of Primary schools?
Keep it short and to the point. -95.46. In the year 1998, what is the difference between the Gross enrolment ratio (%) in Pre-primary schools and Gross enrolment ratio (%) in Secondary schools?
Offer a very short reply. -76.63. In the year 1998, what is the difference between the Gross enrolment ratio (%) of Pre-primary schools and Gross enrolment ratio (%) of Tertiary schools?
Your answer should be very brief. -17.45. In the year 1998, what is the difference between the Gross enrolment ratio (%) of Primary schools and Gross enrolment ratio (%) of Secondary schools?
Your answer should be compact. 18.83. In the year 1998, what is the difference between the Gross enrolment ratio (%) in Primary schools and Gross enrolment ratio (%) in Tertiary schools?
Offer a very short reply. 78. In the year 1998, what is the difference between the Gross enrolment ratio (%) of Secondary schools and Gross enrolment ratio (%) of Tertiary schools?
Ensure brevity in your answer.  59.17. In the year 1999, what is the difference between the Gross enrolment ratio (%) of Pre-primary schools and Gross enrolment ratio (%) of Primary schools?
Give a very brief answer. -100.43. In the year 1999, what is the difference between the Gross enrolment ratio (%) in Pre-primary schools and Gross enrolment ratio (%) in Secondary schools?
Ensure brevity in your answer.  -77.24. In the year 1999, what is the difference between the Gross enrolment ratio (%) of Pre-primary schools and Gross enrolment ratio (%) of Tertiary schools?
Provide a short and direct response. -23.67. In the year 1999, what is the difference between the Gross enrolment ratio (%) of Primary schools and Gross enrolment ratio (%) of Secondary schools?
Keep it short and to the point. 23.18. In the year 1999, what is the difference between the Gross enrolment ratio (%) in Primary schools and Gross enrolment ratio (%) in Tertiary schools?
Your answer should be very brief. 76.76. In the year 1999, what is the difference between the Gross enrolment ratio (%) of Secondary schools and Gross enrolment ratio (%) of Tertiary schools?
Provide a succinct answer. 53.57. In the year 2000, what is the difference between the Gross enrolment ratio (%) in Pre-primary schools and Gross enrolment ratio (%) in Primary schools?
Offer a very short reply. -100.74. In the year 2000, what is the difference between the Gross enrolment ratio (%) of Pre-primary schools and Gross enrolment ratio (%) of Secondary schools?
Keep it short and to the point. -89.22. In the year 2000, what is the difference between the Gross enrolment ratio (%) in Pre-primary schools and Gross enrolment ratio (%) in Tertiary schools?
Ensure brevity in your answer.  -20.93. In the year 2000, what is the difference between the Gross enrolment ratio (%) of Primary schools and Gross enrolment ratio (%) of Secondary schools?
Offer a terse response. 11.52. In the year 2000, what is the difference between the Gross enrolment ratio (%) of Primary schools and Gross enrolment ratio (%) of Tertiary schools?
Provide a succinct answer. 79.81. In the year 2000, what is the difference between the Gross enrolment ratio (%) in Secondary schools and Gross enrolment ratio (%) in Tertiary schools?
Ensure brevity in your answer.  68.29. In the year 2001, what is the difference between the Gross enrolment ratio (%) of Pre-primary schools and Gross enrolment ratio (%) of Primary schools?
Provide a short and direct response. -102.51. In the year 2001, what is the difference between the Gross enrolment ratio (%) in Pre-primary schools and Gross enrolment ratio (%) in Secondary schools?
Offer a terse response. -94.44. In the year 2001, what is the difference between the Gross enrolment ratio (%) in Pre-primary schools and Gross enrolment ratio (%) in Tertiary schools?
Make the answer very short. -21.38. In the year 2001, what is the difference between the Gross enrolment ratio (%) of Primary schools and Gross enrolment ratio (%) of Secondary schools?
Your answer should be very brief. 8.08. In the year 2001, what is the difference between the Gross enrolment ratio (%) of Primary schools and Gross enrolment ratio (%) of Tertiary schools?
Keep it short and to the point. 81.14. In the year 2001, what is the difference between the Gross enrolment ratio (%) of Secondary schools and Gross enrolment ratio (%) of Tertiary schools?
Offer a very short reply. 73.06. In the year 2002, what is the difference between the Gross enrolment ratio (%) of Pre-primary schools and Gross enrolment ratio (%) of Primary schools?
Your answer should be compact. -102.44. In the year 2002, what is the difference between the Gross enrolment ratio (%) of Pre-primary schools and Gross enrolment ratio (%) of Secondary schools?
Ensure brevity in your answer.  -95.66. In the year 2002, what is the difference between the Gross enrolment ratio (%) in Pre-primary schools and Gross enrolment ratio (%) in Tertiary schools?
Your response must be concise. -22.09. In the year 2002, what is the difference between the Gross enrolment ratio (%) of Primary schools and Gross enrolment ratio (%) of Secondary schools?
Your response must be concise. 6.78. In the year 2002, what is the difference between the Gross enrolment ratio (%) in Primary schools and Gross enrolment ratio (%) in Tertiary schools?
Ensure brevity in your answer.  80.36. In the year 2002, what is the difference between the Gross enrolment ratio (%) in Secondary schools and Gross enrolment ratio (%) in Tertiary schools?
Offer a terse response. 73.58. In the year 2003, what is the difference between the Gross enrolment ratio (%) in Pre-primary schools and Gross enrolment ratio (%) in Primary schools?
Provide a short and direct response. -98.33. In the year 2003, what is the difference between the Gross enrolment ratio (%) in Pre-primary schools and Gross enrolment ratio (%) in Secondary schools?
Give a very brief answer. -88.87. In the year 2003, what is the difference between the Gross enrolment ratio (%) in Pre-primary schools and Gross enrolment ratio (%) in Tertiary schools?
Make the answer very short. -22.15. In the year 2003, what is the difference between the Gross enrolment ratio (%) of Primary schools and Gross enrolment ratio (%) of Secondary schools?
Provide a short and direct response. 9.46. In the year 2003, what is the difference between the Gross enrolment ratio (%) in Primary schools and Gross enrolment ratio (%) in Tertiary schools?
Keep it short and to the point. 76.17. In the year 2003, what is the difference between the Gross enrolment ratio (%) in Secondary schools and Gross enrolment ratio (%) in Tertiary schools?
Your answer should be very brief. 66.71. In the year 2004, what is the difference between the Gross enrolment ratio (%) in Pre-primary schools and Gross enrolment ratio (%) in Primary schools?
Your answer should be compact. -97.11. In the year 2004, what is the difference between the Gross enrolment ratio (%) in Pre-primary schools and Gross enrolment ratio (%) in Secondary schools?
Your answer should be compact. -81.69. In the year 2004, what is the difference between the Gross enrolment ratio (%) in Pre-primary schools and Gross enrolment ratio (%) in Tertiary schools?
Your response must be concise. -24.96. In the year 2004, what is the difference between the Gross enrolment ratio (%) of Primary schools and Gross enrolment ratio (%) of Secondary schools?
Ensure brevity in your answer.  15.42. In the year 2004, what is the difference between the Gross enrolment ratio (%) in Primary schools and Gross enrolment ratio (%) in Tertiary schools?
Offer a terse response. 72.15. In the year 2004, what is the difference between the Gross enrolment ratio (%) in Secondary schools and Gross enrolment ratio (%) in Tertiary schools?
Your response must be concise. 56.73. In the year 2005, what is the difference between the Gross enrolment ratio (%) of Pre-primary schools and Gross enrolment ratio (%) of Primary schools?
Your answer should be very brief. -95.08. In the year 2005, what is the difference between the Gross enrolment ratio (%) of Pre-primary schools and Gross enrolment ratio (%) of Secondary schools?
Make the answer very short. -83.57. In the year 2005, what is the difference between the Gross enrolment ratio (%) in Pre-primary schools and Gross enrolment ratio (%) in Tertiary schools?
Your response must be concise. -24.37. In the year 2005, what is the difference between the Gross enrolment ratio (%) of Primary schools and Gross enrolment ratio (%) of Secondary schools?
Keep it short and to the point. 11.51. In the year 2005, what is the difference between the Gross enrolment ratio (%) in Primary schools and Gross enrolment ratio (%) in Tertiary schools?
Offer a very short reply. 70.72. In the year 2005, what is the difference between the Gross enrolment ratio (%) of Secondary schools and Gross enrolment ratio (%) of Tertiary schools?
Ensure brevity in your answer.  59.21. What is the ratio of the Gross enrolment ratio (%) in Pre-primary schools in 1997 to that in 1998?
Keep it short and to the point. 0.96. What is the ratio of the Gross enrolment ratio (%) of Secondary schools in 1997 to that in 1998?
Ensure brevity in your answer.  0.86. What is the ratio of the Gross enrolment ratio (%) of Tertiary schools in 1997 to that in 1998?
Your response must be concise. 1.01. What is the ratio of the Gross enrolment ratio (%) in Pre-primary schools in 1997 to that in 1999?
Your answer should be compact. 1.01. What is the ratio of the Gross enrolment ratio (%) in Primary schools in 1997 to that in 1999?
Make the answer very short. 0.95. What is the ratio of the Gross enrolment ratio (%) of Secondary schools in 1997 to that in 1999?
Offer a terse response. 0.86. What is the ratio of the Gross enrolment ratio (%) of Tertiary schools in 1997 to that in 1999?
Give a very brief answer. 0.82. What is the ratio of the Gross enrolment ratio (%) of Pre-primary schools in 1997 to that in 2000?
Give a very brief answer. 1.06. What is the ratio of the Gross enrolment ratio (%) in Primary schools in 1997 to that in 2000?
Offer a very short reply. 0.95. What is the ratio of the Gross enrolment ratio (%) in Secondary schools in 1997 to that in 2000?
Your answer should be compact. 0.76. What is the ratio of the Gross enrolment ratio (%) in Tertiary schools in 1997 to that in 2000?
Offer a terse response. 0.91. What is the ratio of the Gross enrolment ratio (%) of Pre-primary schools in 1997 to that in 2001?
Your response must be concise. 1.03. What is the ratio of the Gross enrolment ratio (%) in Primary schools in 1997 to that in 2001?
Provide a succinct answer. 0.93. What is the ratio of the Gross enrolment ratio (%) of Secondary schools in 1997 to that in 2001?
Your response must be concise. 0.72. What is the ratio of the Gross enrolment ratio (%) in Tertiary schools in 1997 to that in 2001?
Offer a terse response. 0.89. What is the ratio of the Gross enrolment ratio (%) in Pre-primary schools in 1997 to that in 2002?
Provide a short and direct response. 0.93. What is the ratio of the Gross enrolment ratio (%) in Primary schools in 1997 to that in 2002?
Keep it short and to the point. 0.93. What is the ratio of the Gross enrolment ratio (%) in Secondary schools in 1997 to that in 2002?
Make the answer very short. 0.7. What is the ratio of the Gross enrolment ratio (%) in Tertiary schools in 1997 to that in 2002?
Your answer should be compact. 0.84. What is the ratio of the Gross enrolment ratio (%) of Pre-primary schools in 1997 to that in 2003?
Make the answer very short. 0.85. What is the ratio of the Gross enrolment ratio (%) in Primary schools in 1997 to that in 2003?
Your answer should be very brief. 0.96. What is the ratio of the Gross enrolment ratio (%) in Secondary schools in 1997 to that in 2003?
Give a very brief answer. 0.75. What is the ratio of the Gross enrolment ratio (%) in Tertiary schools in 1997 to that in 2003?
Your answer should be compact. 0.82. What is the ratio of the Gross enrolment ratio (%) of Pre-primary schools in 1997 to that in 2004?
Ensure brevity in your answer.  0.77. What is the ratio of the Gross enrolment ratio (%) of Primary schools in 1997 to that in 2004?
Your answer should be very brief. 0.96. What is the ratio of the Gross enrolment ratio (%) of Secondary schools in 1997 to that in 2004?
Your answer should be compact. 0.8. What is the ratio of the Gross enrolment ratio (%) of Tertiary schools in 1997 to that in 2004?
Keep it short and to the point. 0.73. What is the ratio of the Gross enrolment ratio (%) of Pre-primary schools in 1997 to that in 2005?
Keep it short and to the point. 0.63. What is the ratio of the Gross enrolment ratio (%) of Primary schools in 1997 to that in 2005?
Keep it short and to the point. 0.96. What is the ratio of the Gross enrolment ratio (%) of Secondary schools in 1997 to that in 2005?
Your answer should be very brief. 0.77. What is the ratio of the Gross enrolment ratio (%) of Tertiary schools in 1997 to that in 2005?
Provide a short and direct response. 0.7. What is the ratio of the Gross enrolment ratio (%) in Pre-primary schools in 1998 to that in 1999?
Your answer should be very brief. 1.06. What is the ratio of the Gross enrolment ratio (%) of Primary schools in 1998 to that in 1999?
Offer a terse response. 0.96. What is the ratio of the Gross enrolment ratio (%) of Tertiary schools in 1998 to that in 1999?
Ensure brevity in your answer.  0.81. What is the ratio of the Gross enrolment ratio (%) of Pre-primary schools in 1998 to that in 2000?
Offer a terse response. 1.1. What is the ratio of the Gross enrolment ratio (%) in Primary schools in 1998 to that in 2000?
Offer a very short reply. 0.96. What is the ratio of the Gross enrolment ratio (%) in Secondary schools in 1998 to that in 2000?
Give a very brief answer. 0.88. What is the ratio of the Gross enrolment ratio (%) of Tertiary schools in 1998 to that in 2000?
Your response must be concise. 0.9. What is the ratio of the Gross enrolment ratio (%) in Pre-primary schools in 1998 to that in 2001?
Offer a very short reply. 1.08. What is the ratio of the Gross enrolment ratio (%) in Primary schools in 1998 to that in 2001?
Provide a succinct answer. 0.94. What is the ratio of the Gross enrolment ratio (%) in Secondary schools in 1998 to that in 2001?
Provide a short and direct response. 0.83. What is the ratio of the Gross enrolment ratio (%) of Tertiary schools in 1998 to that in 2001?
Provide a succinct answer. 0.88. What is the ratio of the Gross enrolment ratio (%) in Pre-primary schools in 1998 to that in 2002?
Your answer should be very brief. 0.97. What is the ratio of the Gross enrolment ratio (%) in Primary schools in 1998 to that in 2002?
Your response must be concise. 0.93. What is the ratio of the Gross enrolment ratio (%) of Secondary schools in 1998 to that in 2002?
Offer a very short reply. 0.81. What is the ratio of the Gross enrolment ratio (%) in Tertiary schools in 1998 to that in 2002?
Give a very brief answer. 0.84. What is the ratio of the Gross enrolment ratio (%) in Pre-primary schools in 1998 to that in 2003?
Ensure brevity in your answer.  0.89. What is the ratio of the Gross enrolment ratio (%) of Primary schools in 1998 to that in 2003?
Ensure brevity in your answer.  0.96. What is the ratio of the Gross enrolment ratio (%) in Secondary schools in 1998 to that in 2003?
Provide a short and direct response. 0.86. What is the ratio of the Gross enrolment ratio (%) in Tertiary schools in 1998 to that in 2003?
Ensure brevity in your answer.  0.81. What is the ratio of the Gross enrolment ratio (%) of Pre-primary schools in 1998 to that in 2004?
Provide a short and direct response. 0.8. What is the ratio of the Gross enrolment ratio (%) in Primary schools in 1998 to that in 2004?
Your answer should be compact. 0.97. What is the ratio of the Gross enrolment ratio (%) of Secondary schools in 1998 to that in 2004?
Offer a terse response. 0.92. What is the ratio of the Gross enrolment ratio (%) of Tertiary schools in 1998 to that in 2004?
Your answer should be very brief. 0.73. What is the ratio of the Gross enrolment ratio (%) in Pre-primary schools in 1998 to that in 2005?
Keep it short and to the point. 0.66. What is the ratio of the Gross enrolment ratio (%) in Primary schools in 1998 to that in 2005?
Offer a very short reply. 0.97. What is the ratio of the Gross enrolment ratio (%) in Secondary schools in 1998 to that in 2005?
Offer a terse response. 0.89. What is the ratio of the Gross enrolment ratio (%) of Tertiary schools in 1998 to that in 2005?
Give a very brief answer. 0.7. What is the ratio of the Gross enrolment ratio (%) in Pre-primary schools in 1999 to that in 2000?
Give a very brief answer. 1.04. What is the ratio of the Gross enrolment ratio (%) in Primary schools in 1999 to that in 2000?
Make the answer very short. 1. What is the ratio of the Gross enrolment ratio (%) of Secondary schools in 1999 to that in 2000?
Keep it short and to the point. 0.88. What is the ratio of the Gross enrolment ratio (%) of Tertiary schools in 1999 to that in 2000?
Your response must be concise. 1.11. What is the ratio of the Gross enrolment ratio (%) in Pre-primary schools in 1999 to that in 2001?
Offer a very short reply. 1.02. What is the ratio of the Gross enrolment ratio (%) of Primary schools in 1999 to that in 2001?
Offer a terse response. 0.98. What is the ratio of the Gross enrolment ratio (%) in Secondary schools in 1999 to that in 2001?
Your response must be concise. 0.83. What is the ratio of the Gross enrolment ratio (%) of Tertiary schools in 1999 to that in 2001?
Give a very brief answer. 1.08. What is the ratio of the Gross enrolment ratio (%) of Pre-primary schools in 1999 to that in 2002?
Give a very brief answer. 0.92. What is the ratio of the Gross enrolment ratio (%) of Primary schools in 1999 to that in 2002?
Give a very brief answer. 0.98. What is the ratio of the Gross enrolment ratio (%) of Secondary schools in 1999 to that in 2002?
Give a very brief answer. 0.82. What is the ratio of the Gross enrolment ratio (%) in Tertiary schools in 1999 to that in 2002?
Give a very brief answer. 1.03. What is the ratio of the Gross enrolment ratio (%) in Pre-primary schools in 1999 to that in 2003?
Your response must be concise. 0.84. What is the ratio of the Gross enrolment ratio (%) in Secondary schools in 1999 to that in 2003?
Ensure brevity in your answer.  0.87. What is the ratio of the Gross enrolment ratio (%) of Pre-primary schools in 1999 to that in 2004?
Make the answer very short. 0.76. What is the ratio of the Gross enrolment ratio (%) of Primary schools in 1999 to that in 2004?
Your response must be concise. 1.01. What is the ratio of the Gross enrolment ratio (%) in Secondary schools in 1999 to that in 2004?
Ensure brevity in your answer.  0.93. What is the ratio of the Gross enrolment ratio (%) in Tertiary schools in 1999 to that in 2004?
Offer a terse response. 0.9. What is the ratio of the Gross enrolment ratio (%) of Pre-primary schools in 1999 to that in 2005?
Make the answer very short. 0.62. What is the ratio of the Gross enrolment ratio (%) of Secondary schools in 1999 to that in 2005?
Offer a very short reply. 0.89. What is the ratio of the Gross enrolment ratio (%) of Tertiary schools in 1999 to that in 2005?
Make the answer very short. 0.86. What is the ratio of the Gross enrolment ratio (%) in Pre-primary schools in 2000 to that in 2001?
Offer a terse response. 0.98. What is the ratio of the Gross enrolment ratio (%) of Primary schools in 2000 to that in 2001?
Offer a terse response. 0.98. What is the ratio of the Gross enrolment ratio (%) in Secondary schools in 2000 to that in 2001?
Make the answer very short. 0.95. What is the ratio of the Gross enrolment ratio (%) in Tertiary schools in 2000 to that in 2001?
Ensure brevity in your answer.  0.98. What is the ratio of the Gross enrolment ratio (%) of Pre-primary schools in 2000 to that in 2002?
Your response must be concise. 0.88. What is the ratio of the Gross enrolment ratio (%) of Primary schools in 2000 to that in 2002?
Keep it short and to the point. 0.98. What is the ratio of the Gross enrolment ratio (%) in Secondary schools in 2000 to that in 2002?
Keep it short and to the point. 0.93. What is the ratio of the Gross enrolment ratio (%) of Tertiary schools in 2000 to that in 2002?
Offer a terse response. 0.93. What is the ratio of the Gross enrolment ratio (%) of Pre-primary schools in 2000 to that in 2003?
Give a very brief answer. 0.8. What is the ratio of the Gross enrolment ratio (%) of Primary schools in 2000 to that in 2003?
Ensure brevity in your answer.  1.01. What is the ratio of the Gross enrolment ratio (%) of Secondary schools in 2000 to that in 2003?
Your answer should be very brief. 0.99. What is the ratio of the Gross enrolment ratio (%) of Tertiary schools in 2000 to that in 2003?
Make the answer very short. 0.91. What is the ratio of the Gross enrolment ratio (%) in Pre-primary schools in 2000 to that in 2004?
Ensure brevity in your answer.  0.72. What is the ratio of the Gross enrolment ratio (%) in Primary schools in 2000 to that in 2004?
Your response must be concise. 1.01. What is the ratio of the Gross enrolment ratio (%) in Secondary schools in 2000 to that in 2004?
Your response must be concise. 1.05. What is the ratio of the Gross enrolment ratio (%) of Tertiary schools in 2000 to that in 2004?
Keep it short and to the point. 0.81. What is the ratio of the Gross enrolment ratio (%) of Pre-primary schools in 2000 to that in 2005?
Your answer should be very brief. 0.6. What is the ratio of the Gross enrolment ratio (%) in Primary schools in 2000 to that in 2005?
Offer a terse response. 1.01. What is the ratio of the Gross enrolment ratio (%) in Secondary schools in 2000 to that in 2005?
Provide a short and direct response. 1.01. What is the ratio of the Gross enrolment ratio (%) of Tertiary schools in 2000 to that in 2005?
Ensure brevity in your answer.  0.78. What is the ratio of the Gross enrolment ratio (%) in Pre-primary schools in 2001 to that in 2002?
Provide a succinct answer. 0.9. What is the ratio of the Gross enrolment ratio (%) of Secondary schools in 2001 to that in 2002?
Your answer should be very brief. 0.98. What is the ratio of the Gross enrolment ratio (%) in Tertiary schools in 2001 to that in 2002?
Give a very brief answer. 0.95. What is the ratio of the Gross enrolment ratio (%) in Pre-primary schools in 2001 to that in 2003?
Your response must be concise. 0.82. What is the ratio of the Gross enrolment ratio (%) of Primary schools in 2001 to that in 2003?
Keep it short and to the point. 1.03. What is the ratio of the Gross enrolment ratio (%) in Secondary schools in 2001 to that in 2003?
Keep it short and to the point. 1.04. What is the ratio of the Gross enrolment ratio (%) in Tertiary schools in 2001 to that in 2003?
Your answer should be compact. 0.93. What is the ratio of the Gross enrolment ratio (%) of Pre-primary schools in 2001 to that in 2004?
Keep it short and to the point. 0.74. What is the ratio of the Gross enrolment ratio (%) in Primary schools in 2001 to that in 2004?
Make the answer very short. 1.03. What is the ratio of the Gross enrolment ratio (%) in Secondary schools in 2001 to that in 2004?
Give a very brief answer. 1.11. What is the ratio of the Gross enrolment ratio (%) of Tertiary schools in 2001 to that in 2004?
Give a very brief answer. 0.83. What is the ratio of the Gross enrolment ratio (%) of Pre-primary schools in 2001 to that in 2005?
Your answer should be compact. 0.61. What is the ratio of the Gross enrolment ratio (%) of Primary schools in 2001 to that in 2005?
Your answer should be very brief. 1.03. What is the ratio of the Gross enrolment ratio (%) in Secondary schools in 2001 to that in 2005?
Provide a short and direct response. 1.07. What is the ratio of the Gross enrolment ratio (%) in Tertiary schools in 2001 to that in 2005?
Your answer should be very brief. 0.79. What is the ratio of the Gross enrolment ratio (%) in Pre-primary schools in 2002 to that in 2003?
Offer a terse response. 0.91. What is the ratio of the Gross enrolment ratio (%) in Primary schools in 2002 to that in 2003?
Make the answer very short. 1.03. What is the ratio of the Gross enrolment ratio (%) of Secondary schools in 2002 to that in 2003?
Make the answer very short. 1.06. What is the ratio of the Gross enrolment ratio (%) of Pre-primary schools in 2002 to that in 2004?
Your answer should be very brief. 0.82. What is the ratio of the Gross enrolment ratio (%) in Primary schools in 2002 to that in 2004?
Offer a very short reply. 1.03. What is the ratio of the Gross enrolment ratio (%) in Secondary schools in 2002 to that in 2004?
Offer a very short reply. 1.14. What is the ratio of the Gross enrolment ratio (%) of Tertiary schools in 2002 to that in 2004?
Ensure brevity in your answer.  0.87. What is the ratio of the Gross enrolment ratio (%) in Pre-primary schools in 2002 to that in 2005?
Keep it short and to the point. 0.68. What is the ratio of the Gross enrolment ratio (%) in Primary schools in 2002 to that in 2005?
Offer a very short reply. 1.03. What is the ratio of the Gross enrolment ratio (%) in Secondary schools in 2002 to that in 2005?
Provide a short and direct response. 1.09. What is the ratio of the Gross enrolment ratio (%) in Tertiary schools in 2002 to that in 2005?
Make the answer very short. 0.83. What is the ratio of the Gross enrolment ratio (%) in Pre-primary schools in 2003 to that in 2004?
Keep it short and to the point. 0.9. What is the ratio of the Gross enrolment ratio (%) in Secondary schools in 2003 to that in 2004?
Keep it short and to the point. 1.07. What is the ratio of the Gross enrolment ratio (%) of Tertiary schools in 2003 to that in 2004?
Your answer should be compact. 0.89. What is the ratio of the Gross enrolment ratio (%) of Pre-primary schools in 2003 to that in 2005?
Provide a short and direct response. 0.74. What is the ratio of the Gross enrolment ratio (%) of Primary schools in 2003 to that in 2005?
Make the answer very short. 1. What is the ratio of the Gross enrolment ratio (%) in Secondary schools in 2003 to that in 2005?
Your response must be concise. 1.03. What is the ratio of the Gross enrolment ratio (%) of Tertiary schools in 2003 to that in 2005?
Keep it short and to the point. 0.86. What is the ratio of the Gross enrolment ratio (%) in Pre-primary schools in 2004 to that in 2005?
Offer a terse response. 0.82. What is the ratio of the Gross enrolment ratio (%) of Primary schools in 2004 to that in 2005?
Provide a succinct answer. 1. What is the ratio of the Gross enrolment ratio (%) of Secondary schools in 2004 to that in 2005?
Offer a terse response. 0.96. What is the ratio of the Gross enrolment ratio (%) in Tertiary schools in 2004 to that in 2005?
Provide a succinct answer. 0.96. What is the difference between the highest and the second highest Gross enrolment ratio (%) of Pre-primary schools?
Offer a very short reply. 2.01. What is the difference between the highest and the second highest Gross enrolment ratio (%) of Primary schools?
Offer a very short reply. 0.68. What is the difference between the highest and the second highest Gross enrolment ratio (%) in Secondary schools?
Make the answer very short. 1.98. What is the difference between the highest and the second highest Gross enrolment ratio (%) in Tertiary schools?
Offer a very short reply. 1.42. What is the difference between the highest and the lowest Gross enrolment ratio (%) in Pre-primary schools?
Offer a very short reply. 4.56. What is the difference between the highest and the lowest Gross enrolment ratio (%) of Primary schools?
Keep it short and to the point. 7.83. What is the difference between the highest and the lowest Gross enrolment ratio (%) in Secondary schools?
Give a very brief answer. 30.62. What is the difference between the highest and the lowest Gross enrolment ratio (%) of Tertiary schools?
Provide a succinct answer. 10.78. 